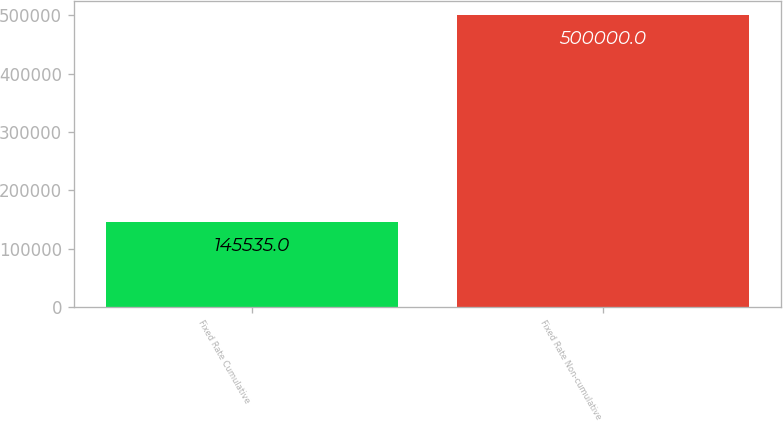Convert chart. <chart><loc_0><loc_0><loc_500><loc_500><bar_chart><fcel>Fixed Rate Cumulative<fcel>Fixed Rate Non-cumulative<nl><fcel>145535<fcel>500000<nl></chart> 